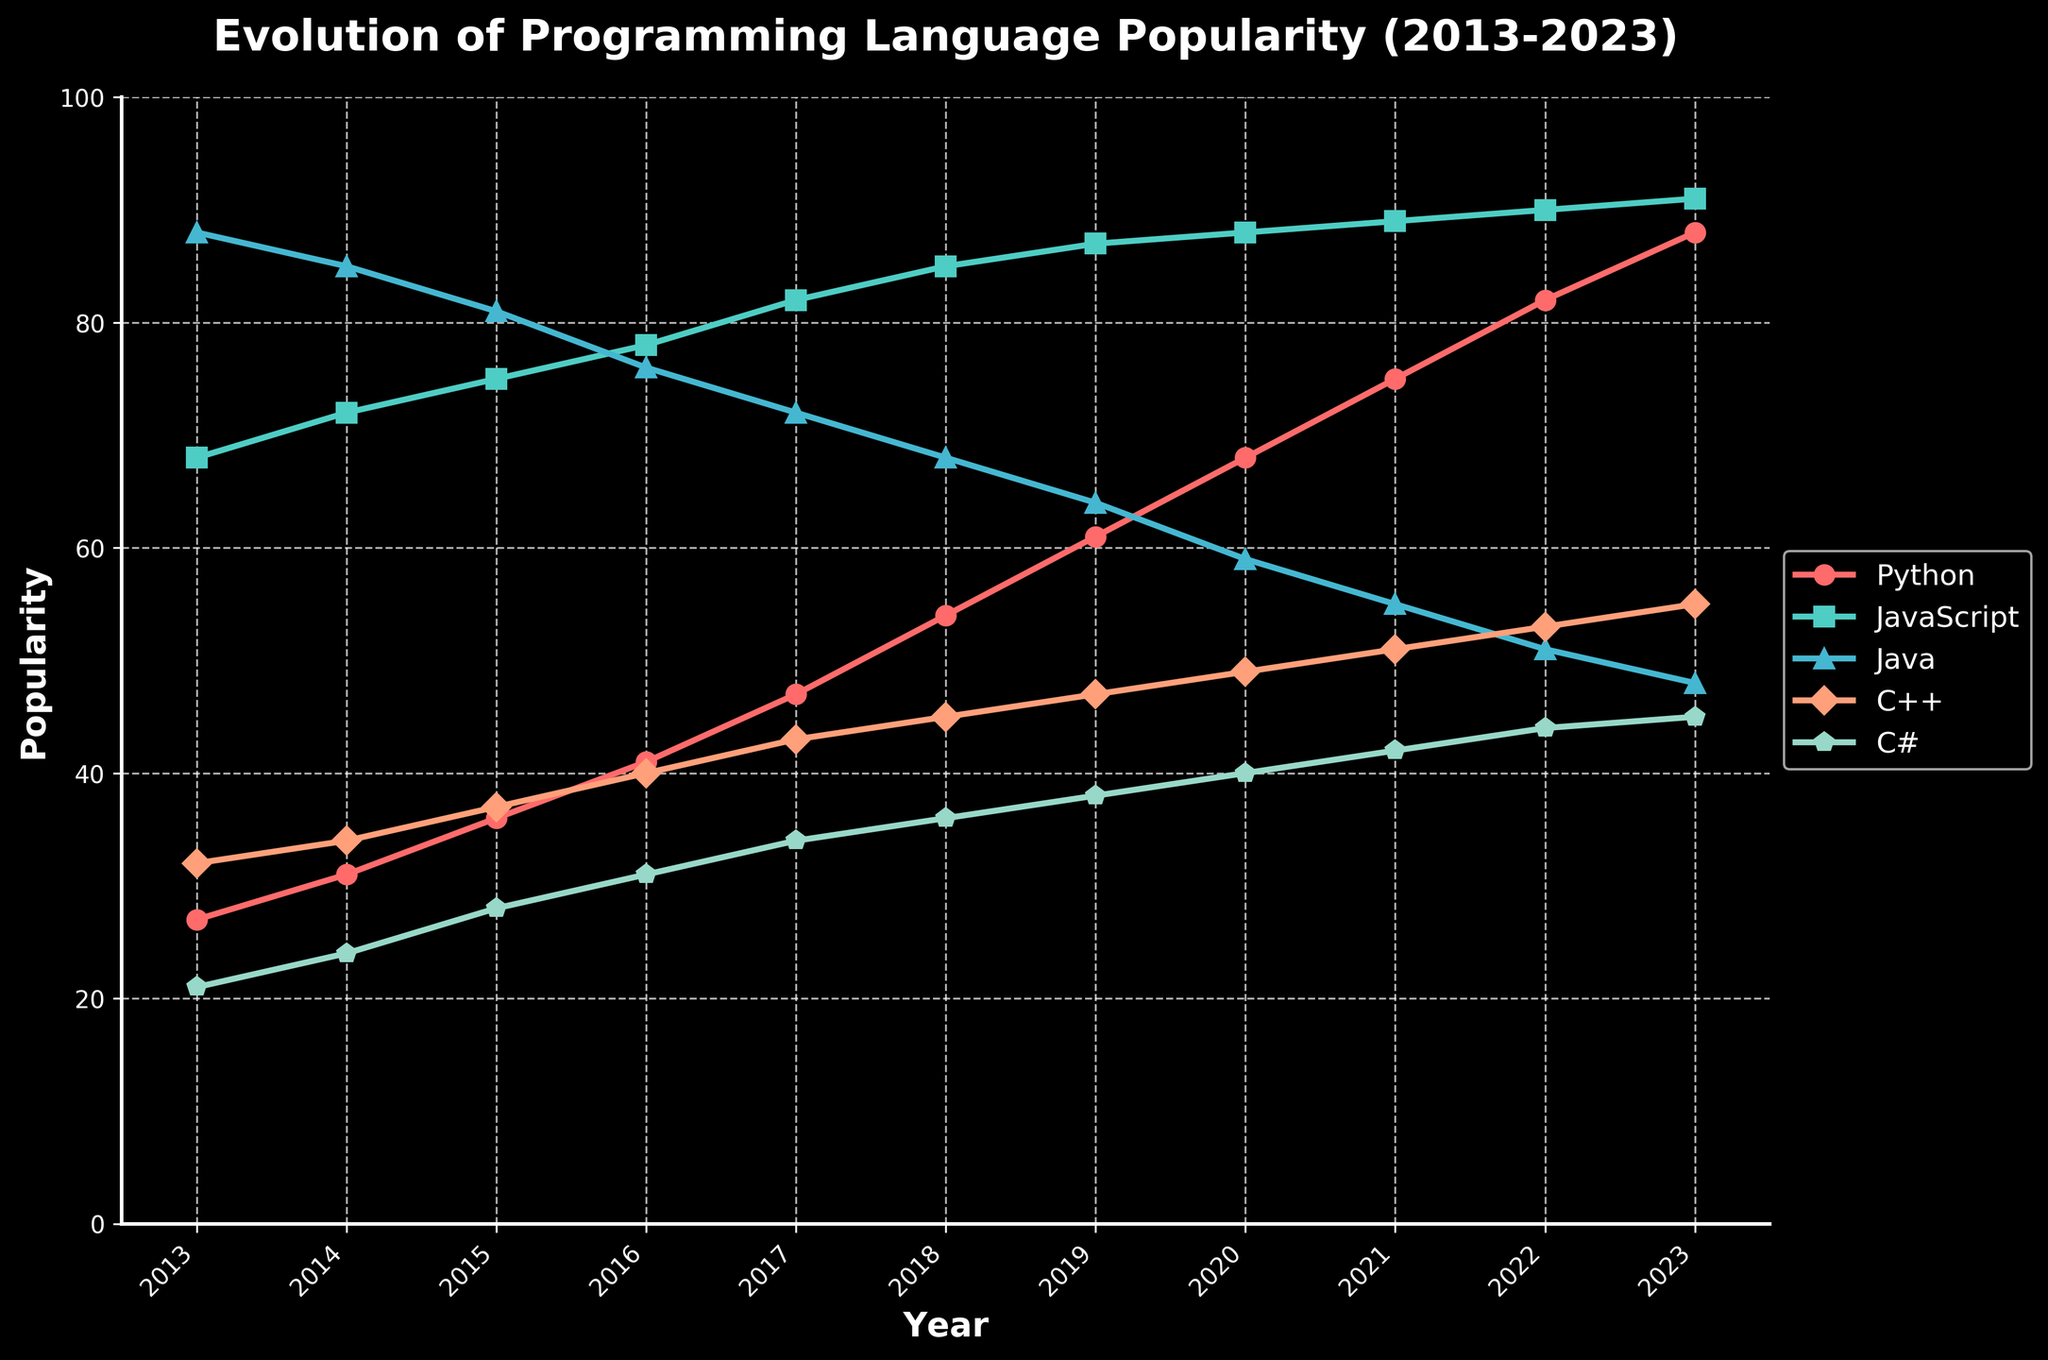What language experienced the largest increase in popularity between 2013 and 2023? To determine this, calculate the difference in popularity for each language from 2013 to 2023. Python increased from 27 to 88 (61), JavaScript from 68 to 91 (23), Java from 88 to 48 (-40), C++ from 32 to 55 (23), and C# from 21 to 45 (24). Python shows the largest increase.
Answer: Python Which language had the highest popularity in 2023? Look at the chart data for 2023. The popularity values are Python (88), JavaScript (91), Java (48), C++ (55), and C# (45). The highest value is 91 for JavaScript.
Answer: JavaScript What year did Python overtake Java in popularity? Compare the popularity values of Python and Java for each year. Python surpasses Java in 2019 when Python is at 61 and Java is at 64.
Answer: 2019 In which year were Python and JavaScript’s popularity closest to each other? Look for the smallest difference between Python and JavaScript values across the years. In 2023, Python is 88, and JavaScript is 91, making the difference 3, the smallest throughout the years.
Answer: 2023 Which language had a consistent increase in popularity every year? Check each language's yearly values. Python consistently increases from 2013 to 2023. The others have fluctuations.
Answer: Python Between 2017 and 2019, which language had the smallest increase in popularity? Calculate the differences between 2017 and 2019 values for each language: Python (14), JavaScript (5), Java (-8), C++ (4), C# (4). JavaScript and C++ have the smallest increase of 5.
Answer: JavaScript, C++ What is the average popularity of C# from 2013 to 2023? Sum the yearly values for C# and divide by the number of years: (21 + 24 + 28 + 31 + 34 + 36 + 38 + 40 + 42 + 44 + 45) / 11 = 34.
Answer: 34 Which language had the highest decline in popularity from 2013 to 2023? Calculate the differences in popularity for each language: Python (+61), JavaScript (+23), Java (-40), C++ (+23), C# (+24). Java declines by 40, the highest decline.
Answer: Java Compare the popularity of C++ and C# in 2017. Which one was more popular and by how much? Look at the 2017 values: C++ (43), C# (34). Difference is 43 - 34 = 9, so C++ is more popular by 9.
Answer: C++, by 9 In which year does JavaScript reach its highest popularity? Identify the highest value of JavaScript in the timeline, which is 91 reached in 2023.
Answer: 2023 